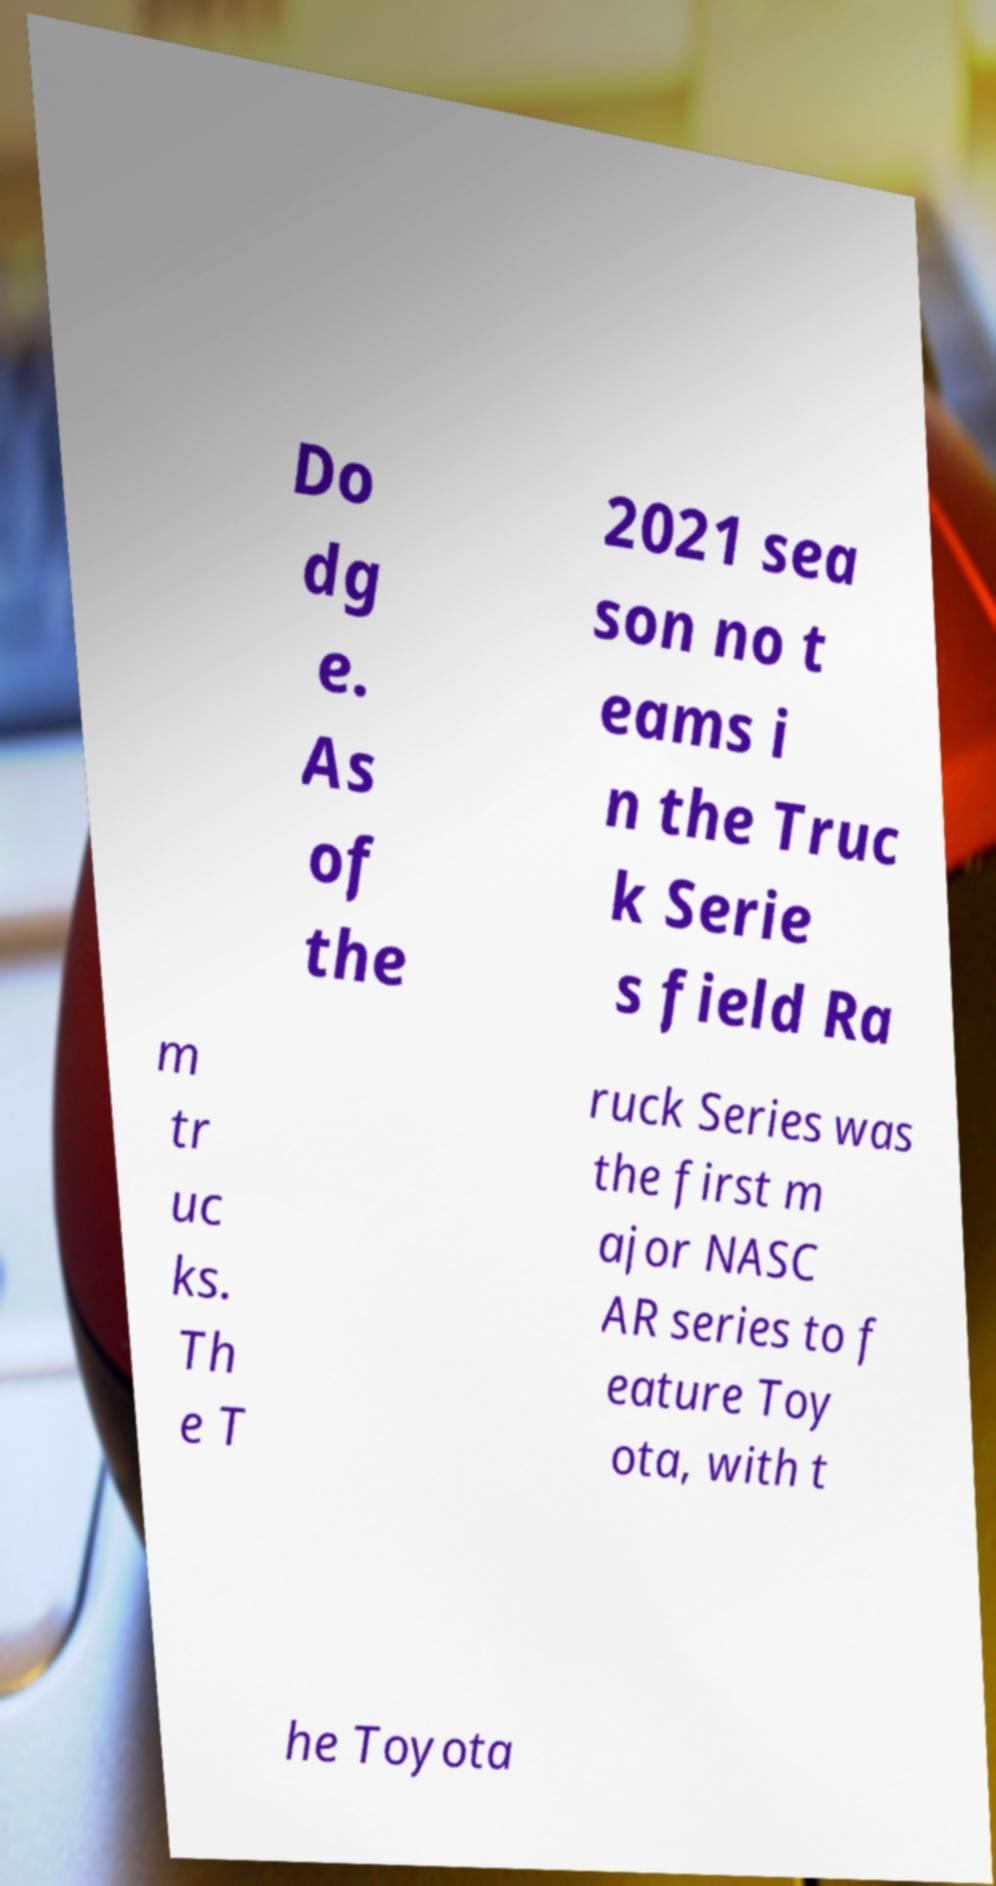Please read and relay the text visible in this image. What does it say? Do dg e. As of the 2021 sea son no t eams i n the Truc k Serie s field Ra m tr uc ks. Th e T ruck Series was the first m ajor NASC AR series to f eature Toy ota, with t he Toyota 